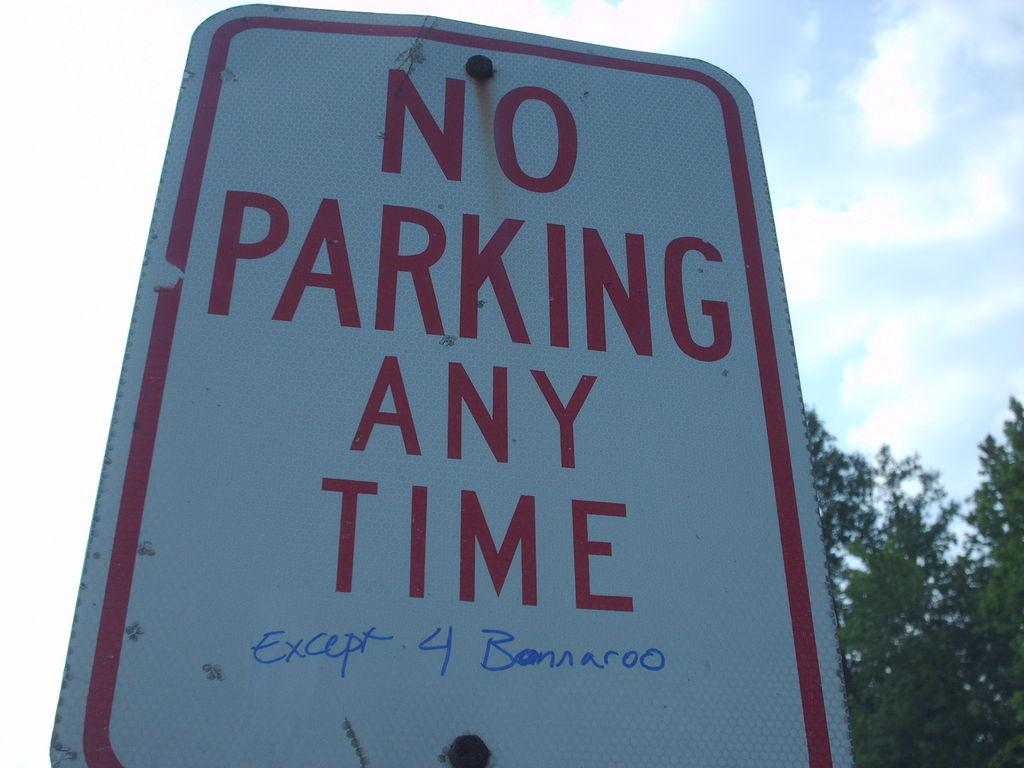<image>
Share a concise interpretation of the image provided. A sign that indicates no parking at any time. 